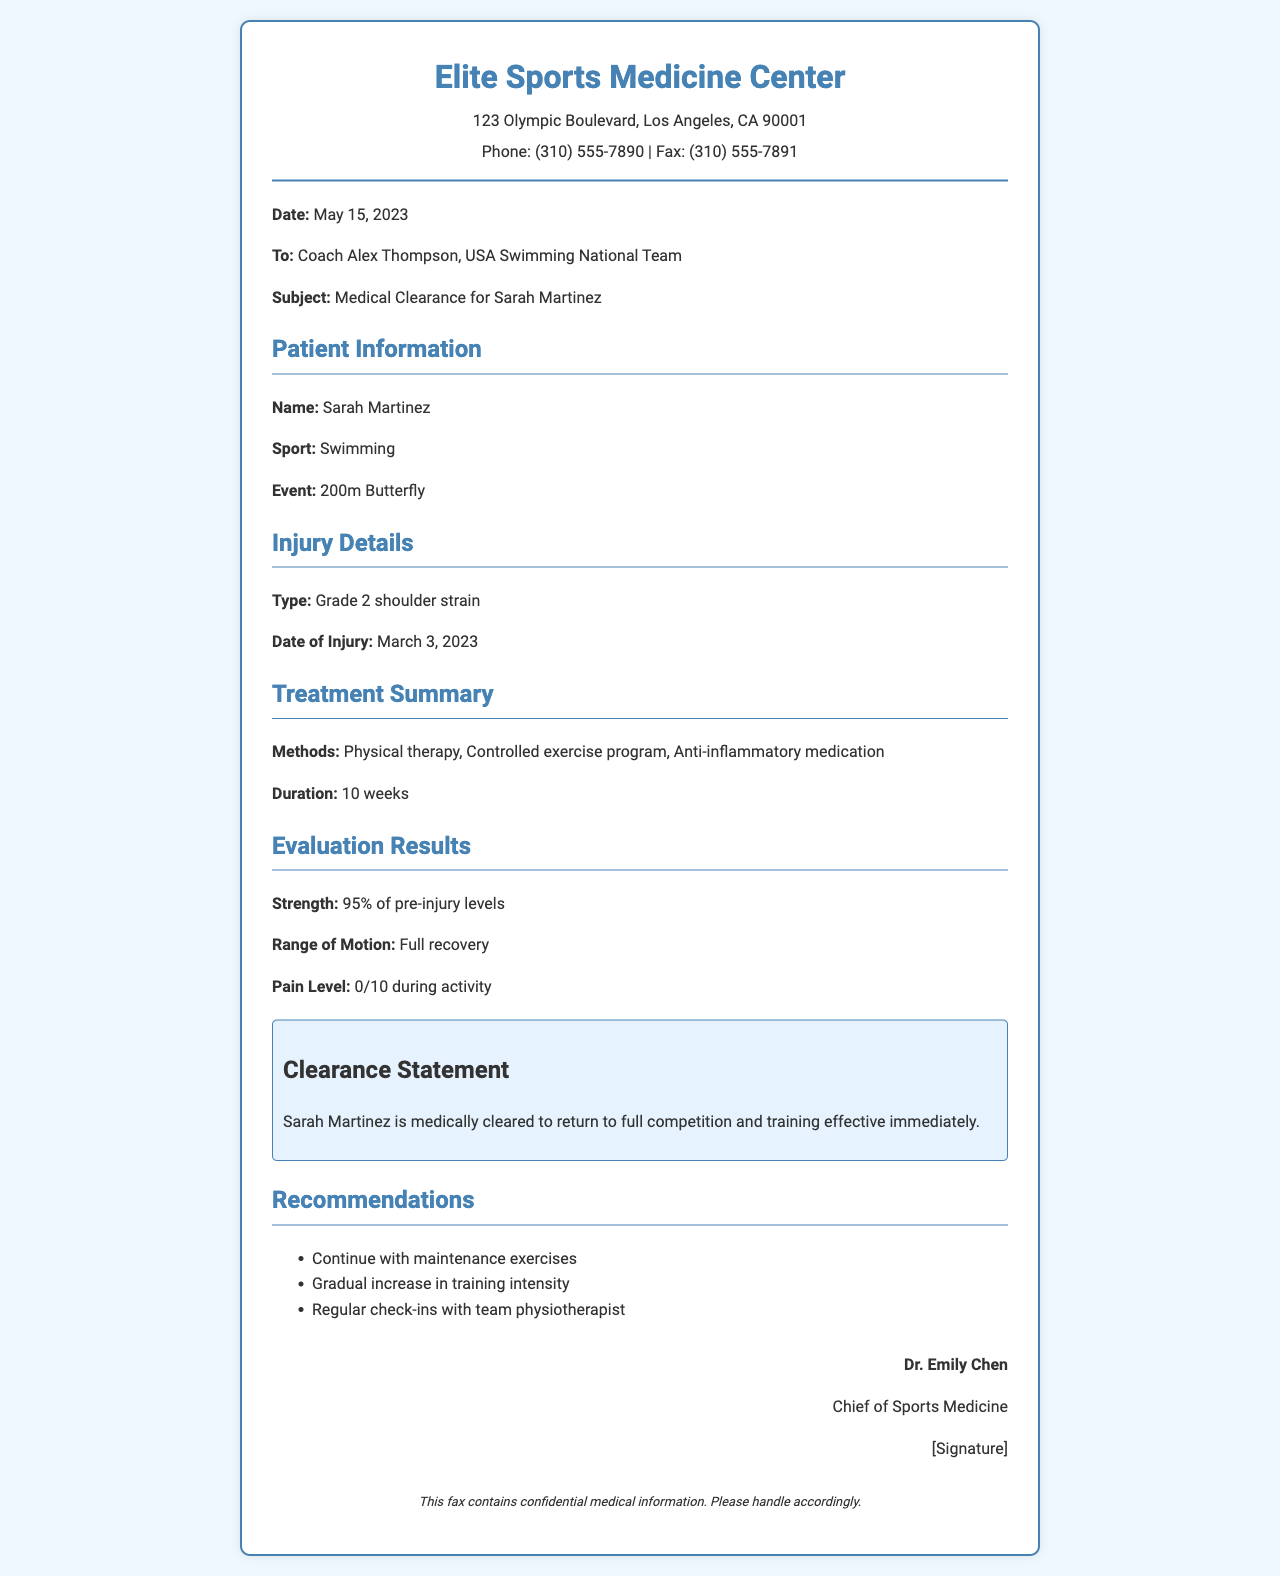What is the name of the patient? The patient's name is mentioned in the document as Sarah Martinez.
Answer: Sarah Martinez What is the date of the fax? The date is explicitly stated in the document as May 15, 2023.
Answer: May 15, 2023 What type of injury did the athlete sustain? The document specifies that the type of injury is a Grade 2 shoulder strain.
Answer: Grade 2 shoulder strain What percentage of strength has the athlete regained? The document indicates that the athlete has regained 95% of her pre-injury strength.
Answer: 95% What recommendations are provided for the athlete? The document includes recommendations that consist of three items related to her training and recovery.
Answer: Continue with maintenance exercises, gradual increase in training intensity, regular check-ins with team physiotherapist Who is the signatory of the document? The document clearly states that the signatory is Dr. Emily Chen, Chief of Sports Medicine.
Answer: Dr. Emily Chen What sport does Sarah Martinez compete in? The document provides the sport Sarah Martinez competes in, which is swimming.
Answer: Swimming What event is mentioned for Sarah Martinez? The 200m Butterfly is specifically mentioned as the event for Sarah Martinez.
Answer: 200m Butterfly 